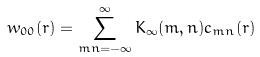Convert formula to latex. <formula><loc_0><loc_0><loc_500><loc_500>w _ { 0 0 } ( { r } ) = \sum _ { m n = - \infty } ^ { \infty } K _ { \infty } ( m , n ) c _ { m n } ( { r } )</formula> 